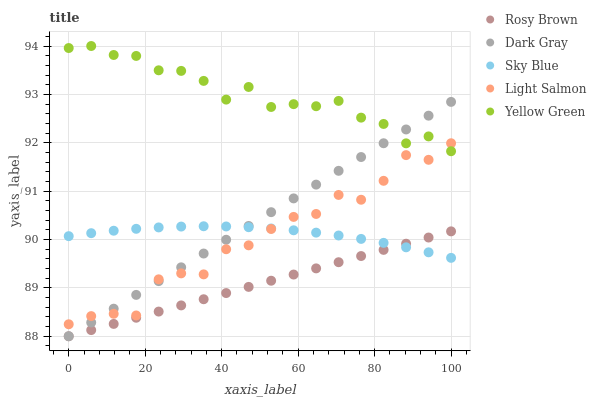Does Rosy Brown have the minimum area under the curve?
Answer yes or no. Yes. Does Yellow Green have the maximum area under the curve?
Answer yes or no. Yes. Does Sky Blue have the minimum area under the curve?
Answer yes or no. No. Does Sky Blue have the maximum area under the curve?
Answer yes or no. No. Is Rosy Brown the smoothest?
Answer yes or no. Yes. Is Light Salmon the roughest?
Answer yes or no. Yes. Is Sky Blue the smoothest?
Answer yes or no. No. Is Sky Blue the roughest?
Answer yes or no. No. Does Dark Gray have the lowest value?
Answer yes or no. Yes. Does Sky Blue have the lowest value?
Answer yes or no. No. Does Yellow Green have the highest value?
Answer yes or no. Yes. Does Sky Blue have the highest value?
Answer yes or no. No. Is Rosy Brown less than Light Salmon?
Answer yes or no. Yes. Is Yellow Green greater than Rosy Brown?
Answer yes or no. Yes. Does Light Salmon intersect Yellow Green?
Answer yes or no. Yes. Is Light Salmon less than Yellow Green?
Answer yes or no. No. Is Light Salmon greater than Yellow Green?
Answer yes or no. No. Does Rosy Brown intersect Light Salmon?
Answer yes or no. No. 